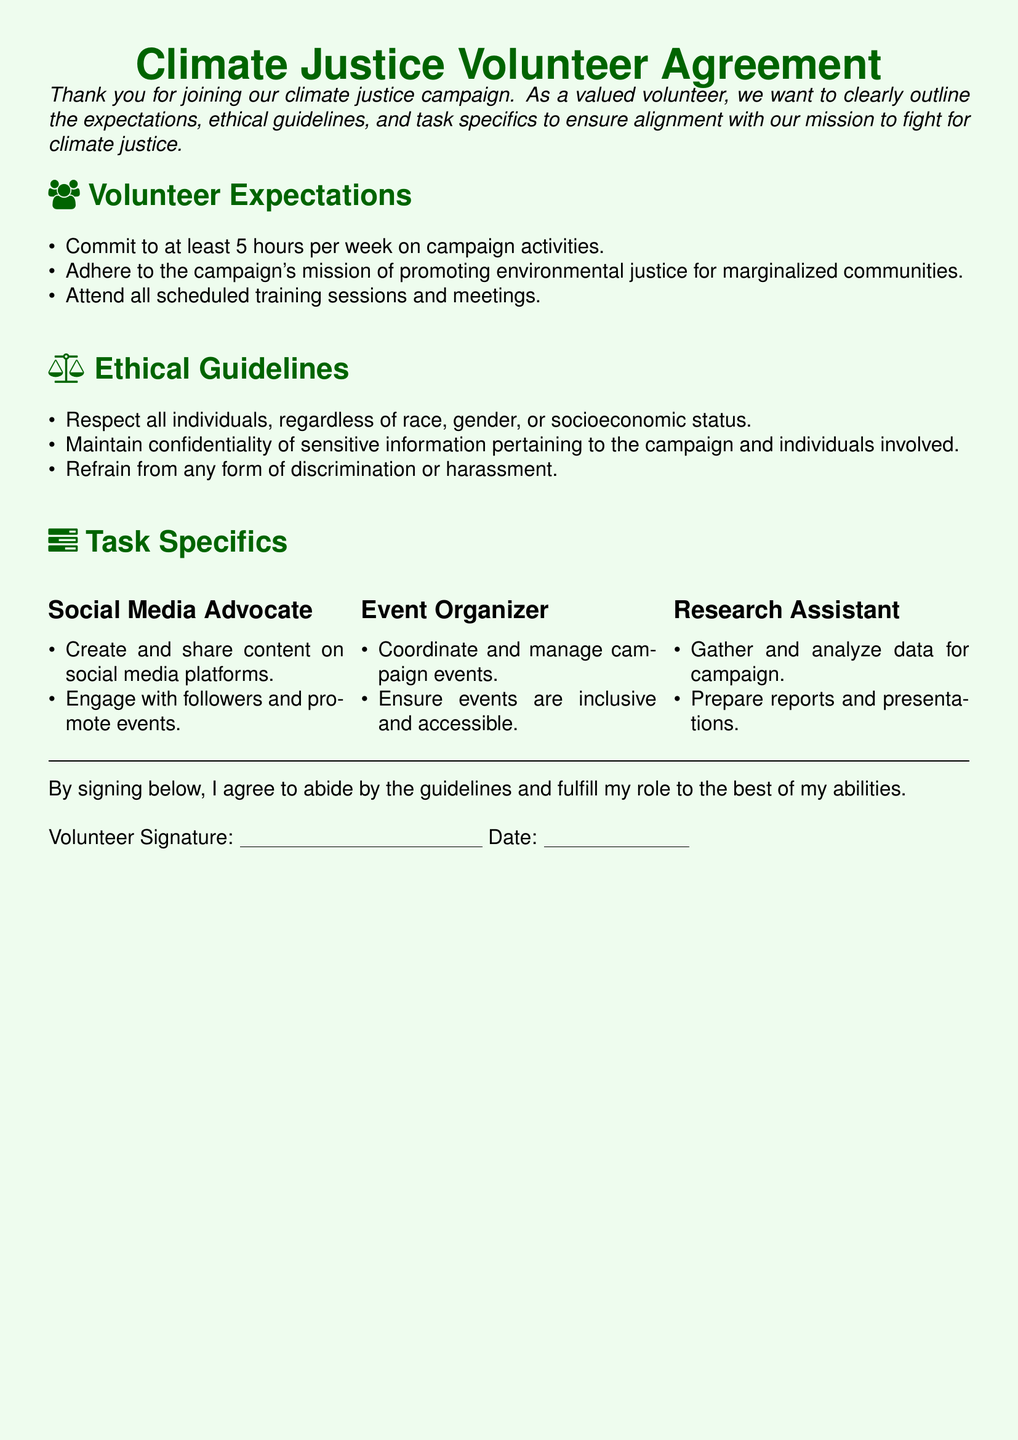What is the minimum weekly time commitment for volunteers? The document states that volunteers must commit to at least 5 hours per week on campaign activities.
Answer: 5 hours What is a core mission of the campaign? The document mentions the campaign's mission of promoting environmental justice for marginalized communities.
Answer: Environmental justice for marginalized communities What are the two ethical guidelines that volunteers must follow? The document lists respecting all individuals and maintaining confidentiality as ethical guidelines.
Answer: Respect individuals, Maintain confidentiality What type of role involves creating and sharing content? The document specifies the role of Social Media Advocate involves creating and sharing content on social media platforms.
Answer: Social Media Advocate How many task categories are defined in the document? The document outlines three specific task categories for volunteers: Social Media Advocate, Event Organizer, and Research Assistant.
Answer: 3 What must volunteers refrain from according to the ethical guidelines? The document states that volunteers must refrain from any form of discrimination or harassment.
Answer: Discrimination or harassment What is required from volunteers during scheduled meetings? Volunteers are expected to attend all scheduled training sessions and meetings as outlined in the document.
Answer: Attend all scheduled meetings What is the document's overall purpose? The document serves as a Volunteer Agreement to clearly outline expectations, ethical guidelines, and task specifics for volunteers in a climate justice campaign.
Answer: Volunteer Agreement Which section mentions coordinating and managing campaign events? The section under Task Specifics for the role of Event Organizer mentions this responsibility.
Answer: Event Organizer 